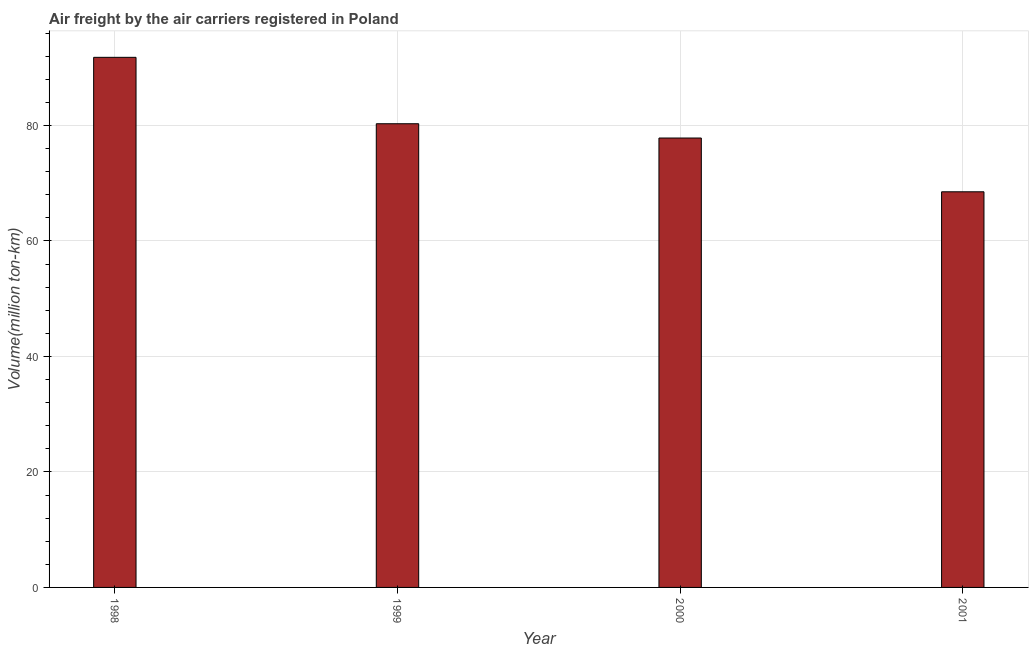Does the graph contain any zero values?
Your response must be concise. No. Does the graph contain grids?
Your answer should be compact. Yes. What is the title of the graph?
Keep it short and to the point. Air freight by the air carriers registered in Poland. What is the label or title of the X-axis?
Ensure brevity in your answer.  Year. What is the label or title of the Y-axis?
Your answer should be compact. Volume(million ton-km). What is the air freight in 1998?
Give a very brief answer. 91.8. Across all years, what is the maximum air freight?
Give a very brief answer. 91.8. Across all years, what is the minimum air freight?
Your answer should be very brief. 68.51. In which year was the air freight minimum?
Provide a succinct answer. 2001. What is the sum of the air freight?
Provide a short and direct response. 318.44. What is the difference between the air freight in 1999 and 2000?
Give a very brief answer. 2.47. What is the average air freight per year?
Provide a succinct answer. 79.61. What is the median air freight?
Keep it short and to the point. 79.06. In how many years, is the air freight greater than 32 million ton-km?
Make the answer very short. 4. What is the ratio of the air freight in 1999 to that in 2000?
Keep it short and to the point. 1.03. Is the sum of the air freight in 1999 and 2001 greater than the maximum air freight across all years?
Offer a terse response. Yes. What is the difference between the highest and the lowest air freight?
Provide a succinct answer. 23.29. Are all the bars in the graph horizontal?
Make the answer very short. No. Are the values on the major ticks of Y-axis written in scientific E-notation?
Keep it short and to the point. No. What is the Volume(million ton-km) in 1998?
Your answer should be compact. 91.8. What is the Volume(million ton-km) in 1999?
Your answer should be very brief. 80.3. What is the Volume(million ton-km) of 2000?
Provide a succinct answer. 77.83. What is the Volume(million ton-km) of 2001?
Keep it short and to the point. 68.51. What is the difference between the Volume(million ton-km) in 1998 and 1999?
Your answer should be very brief. 11.5. What is the difference between the Volume(million ton-km) in 1998 and 2000?
Your answer should be compact. 13.97. What is the difference between the Volume(million ton-km) in 1998 and 2001?
Your answer should be very brief. 23.29. What is the difference between the Volume(million ton-km) in 1999 and 2000?
Your answer should be compact. 2.47. What is the difference between the Volume(million ton-km) in 1999 and 2001?
Offer a terse response. 11.79. What is the difference between the Volume(million ton-km) in 2000 and 2001?
Offer a terse response. 9.31. What is the ratio of the Volume(million ton-km) in 1998 to that in 1999?
Offer a very short reply. 1.14. What is the ratio of the Volume(million ton-km) in 1998 to that in 2000?
Offer a terse response. 1.18. What is the ratio of the Volume(million ton-km) in 1998 to that in 2001?
Make the answer very short. 1.34. What is the ratio of the Volume(million ton-km) in 1999 to that in 2000?
Provide a short and direct response. 1.03. What is the ratio of the Volume(million ton-km) in 1999 to that in 2001?
Your answer should be very brief. 1.17. What is the ratio of the Volume(million ton-km) in 2000 to that in 2001?
Offer a very short reply. 1.14. 